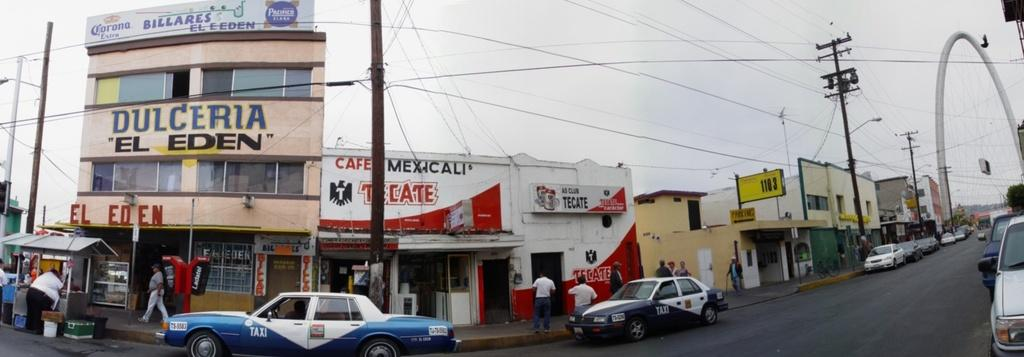Provide a one-sentence caption for the provided image. Two blue and white police cars are parked in front of a cafe with the signage cafe mexicali. 